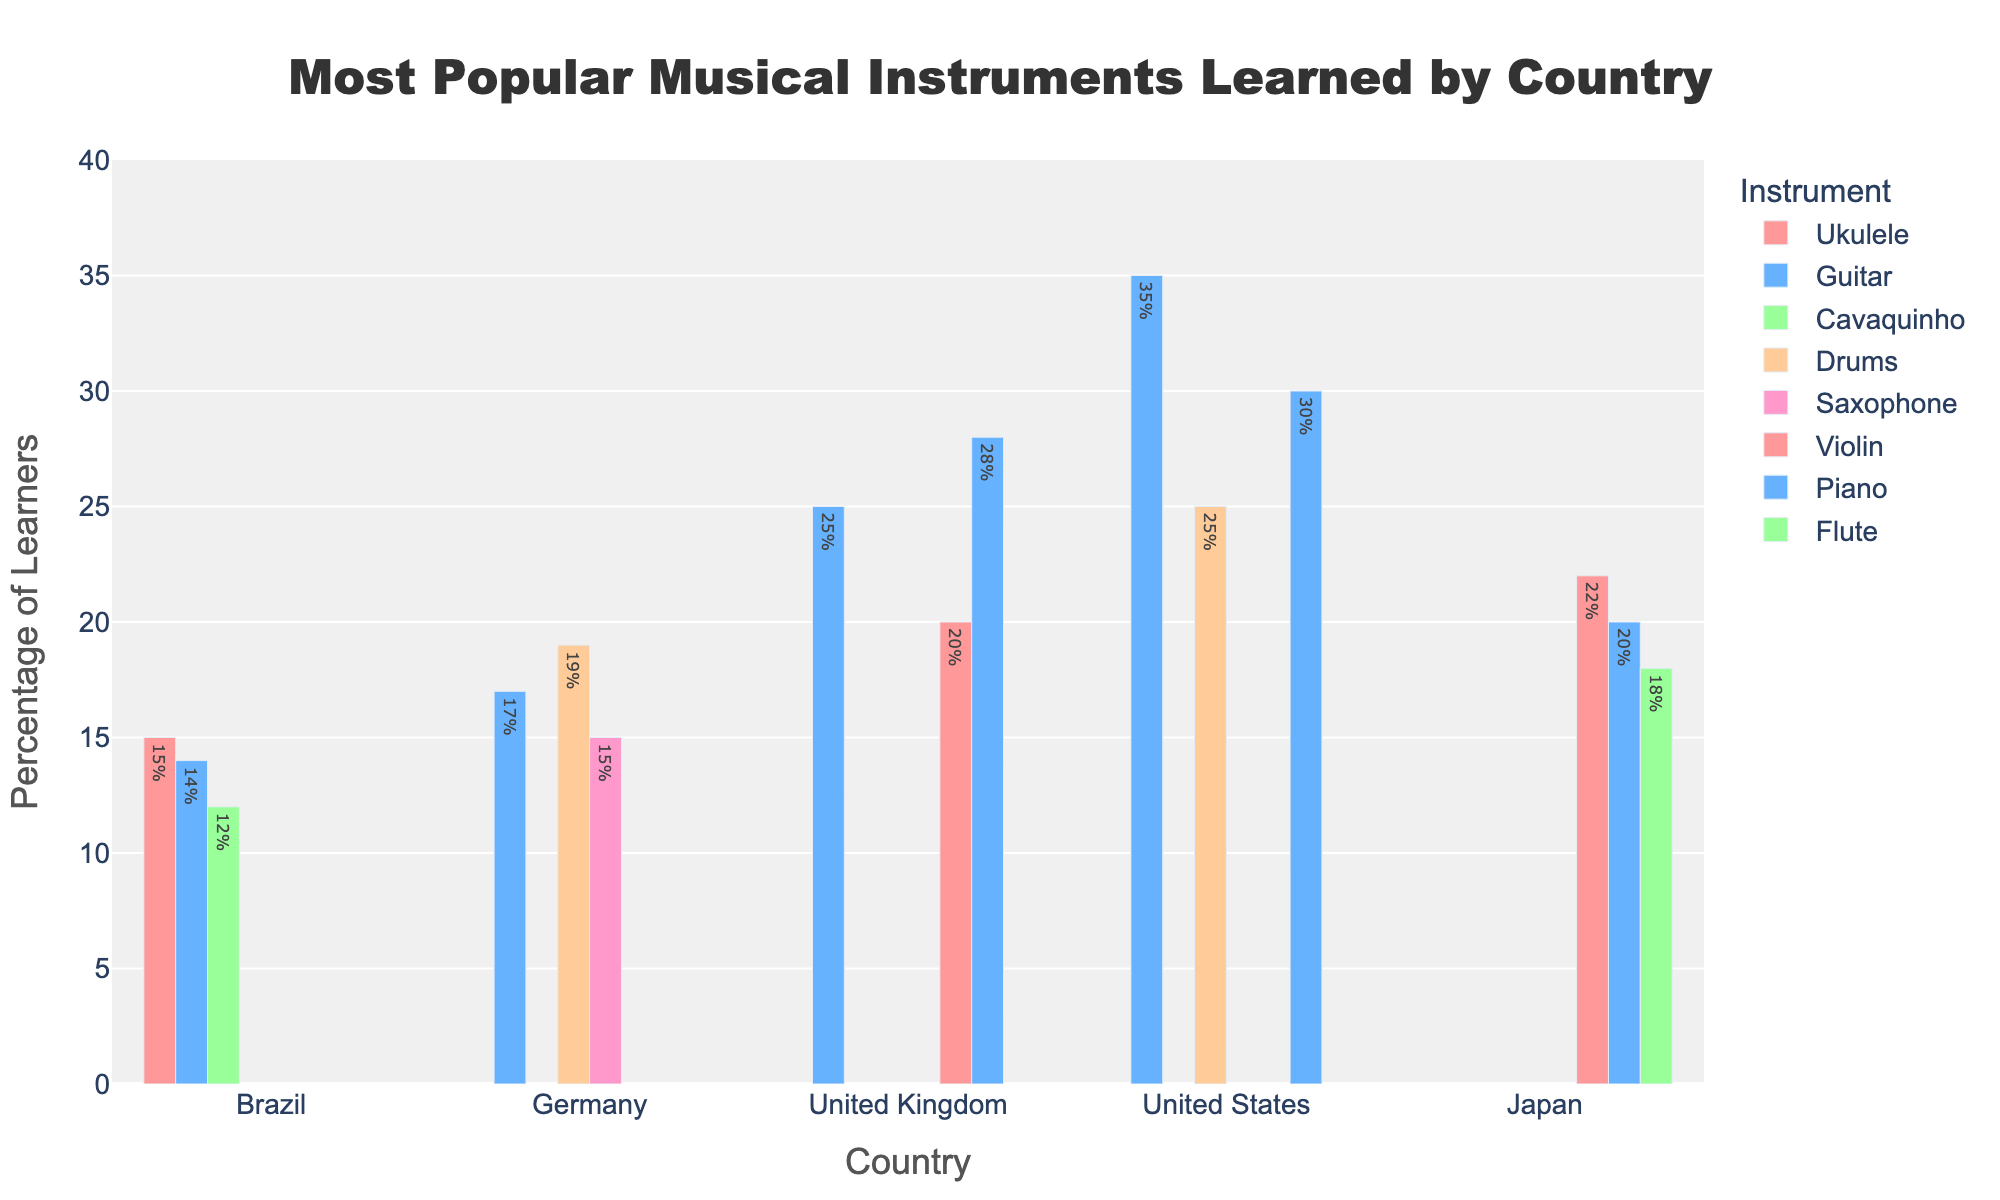What's the most popular musical instrument learned in the United States? To determine the most popular musical instrument in the United States, look at the heights of the bars for the United States. The Guitar has the highest percentage at 35%.
Answer: Guitar Which country has the highest percentage of learners for the Ukulele? To find this, identify the Ukulele bar and compare its height across all countries. Brazil has the highest percentage at 15%.
Answer: Brazil Which instrument is learned by more people in Japan, the Violin or the Flute? Compare the heights of the bars for the Violin and the Flute in Japan. The Violin has a higher percentage at 22%, while the Flute is at 18%.
Answer: Violin Which country has the lowest percentage of learners for the Guitar? Identify and compare the Guitar bars across all countries. The lowest percentage is in Brazil with 14%.
Answer: Brazil What is the total percentage of learners for Piano in the United States and Japan combined? Add the percentages for Piano in the United States and Japan. 30% + 20% = 50%
Answer: 50% Which instrument has the second highest percentage of learners in Germany? First, identify the instruments and percentages for Germany. The highest is Guitar at 17%, followed by Drums at 19%, so the second highest is Drums.
Answer: Drums Compare the popularity of the Violin in the United Kingdom and the United States. Which country has more learners? Look at the heights of the Violin bars for both countries. The United Kingdom has a 20% learner rate, whereas the United States is not listed for Violin, hence the United Kingdom has more learners.
Answer: United Kingdom How many more people (in percentage points) learn the Guitar compared to the Ukulele in the United States? Look at the percentage for Guitar and Ukulele in the United States. Guitar is 35%, while Ukulele is not listed, so the outcome is just 35%.
Answer: 35% What percentage of learners in Brazil learn the Cavaquinho? Identify the bar for the Cavaquinho in Brazil, which is 12%.
Answer: 12% Between Piano and Drums, which is more popular in the United States and by how much? Identify and compare the heights of the Piano and Drums bars. Piano is at 30% and Drums at 25%. The difference is 30% - 25% = 5%.
Answer: Piano by 5% 